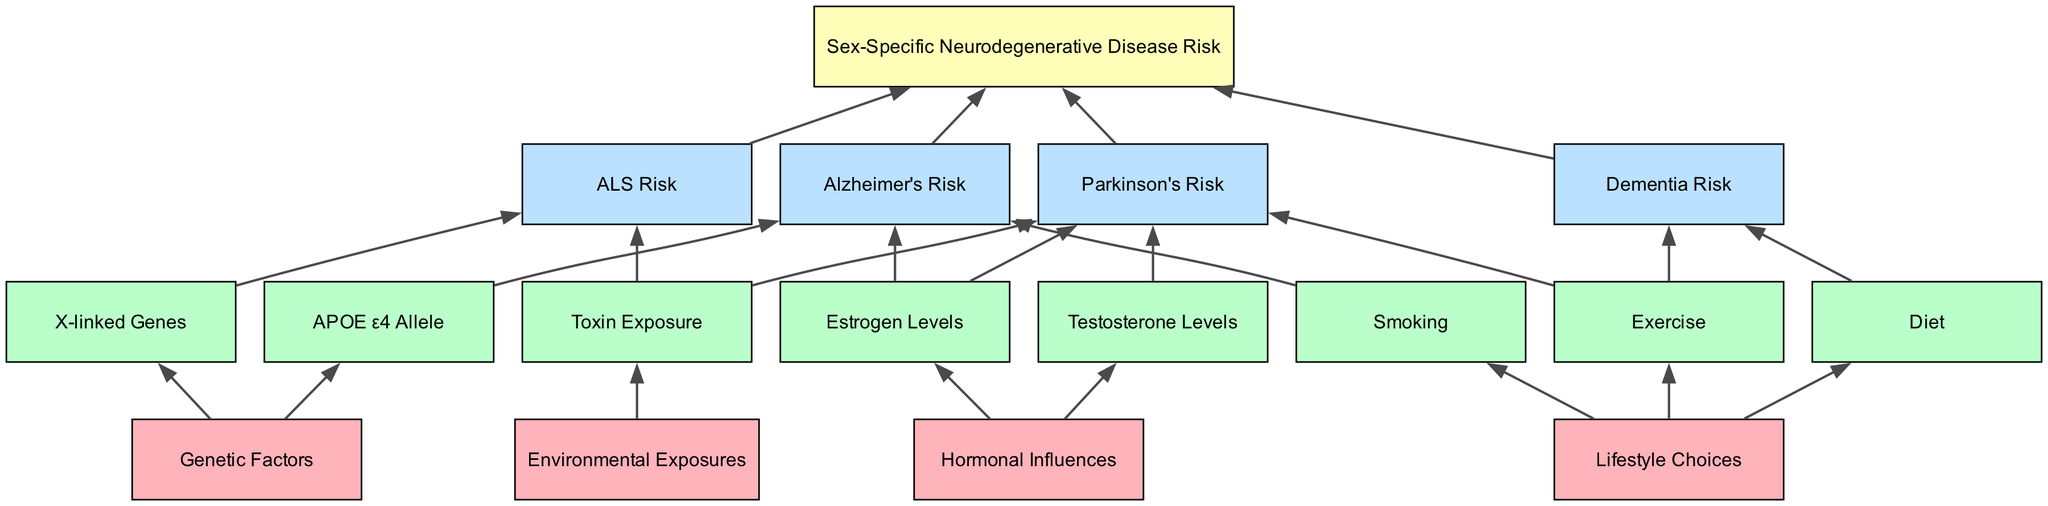What are the first-level factors in the diagram? The first-level factors are listed at the top of the diagram and include "Genetic Factors," "Hormonal Influences," "Lifestyle Choices," and "Environmental Exposures."
Answer: Genetic Factors, Hormonal Influences, Lifestyle Choices, Environmental Exposures Which genetic factor is linked to Alzheimer's Risk? The diagram indicates that the "APOE ε4 Allele" directly leads to "Alzheimer's Risk." Therefore, this is the genetic factor involved.
Answer: APOE ε4 Allele How many items are in the second level? By counting the items in the second level of the diagram, we see there are eight items: "APOE ε4 Allele," "X-linked Genes," "Estrogen Levels," "Testosterone Levels," "Diet," "Exercise," "Smoking," and "Toxin Exposure."
Answer: 8 Which hormonal factor is related to both Alzheimer's and Parkinson's risks? The "Estrogen Levels" are shown to influence both "Alzheimer's Risk" and "Parkinson's Risk" in the diagram. Hence, it is the factor associated with both conditions.
Answer: Estrogen Levels How are lifestyle choices connected to dementia risk? The diagram shows that "Diet" and "Exercise" are lifestyle choices that each have a direct connection to "Dementia Risk." Both items link to this specific risk.
Answer: Diet, Exercise What is the final outcome related to neurodegenerative risks? The diagram terminates with the node "Sex-Specific Neurodegenerative Disease Risk," indicating that all other risks funnel into this final outcome.
Answer: Sex-Specific Neurodegenerative Disease Risk Which environmental exposure is connected to both Parkinson's and ALS risks? "Toxin Exposure" is shown in the diagram to have connections leading to both "Parkinson's Risk" and "ALS Risk." This exposure is significant in relation to these diseases.
Answer: Toxin Exposure What factors contribute to Parkinson's Risk in the diagram? The factors contributing to "Parkinson's Risk" as per the diagram include "Estrogen Levels," "Testosterone Levels," "Exercise," and "Toxin Exposure," indicating their combined effect on this risk.
Answer: Estrogen Levels, Testosterone Levels, Exercise, Toxin Exposure How many distinct neurodegenerative diseases are represented in the third level? The diagram shows four distinct neurodegenerative diseases represented in the third level: "Alzheimer's Risk," "Parkinson's Risk," "ALS Risk," and "Dementia Risk."
Answer: 4 